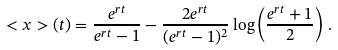<formula> <loc_0><loc_0><loc_500><loc_500>< x > ( t ) = \frac { e ^ { r t } } { e ^ { r t } - 1 } - \frac { 2 e ^ { r t } } { ( e ^ { r t } - 1 ) ^ { 2 } } \log \left ( \frac { e ^ { r t } + 1 } { 2 } \right ) \, .</formula> 